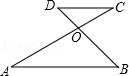Articulate your interpretation of the image. In the given diagram, there are two parallel lines named AB and CD. Point O represents the intersection of lines AC and BD. The diagram includes angles A and D. At point O, there is an angle labeled AOB. 